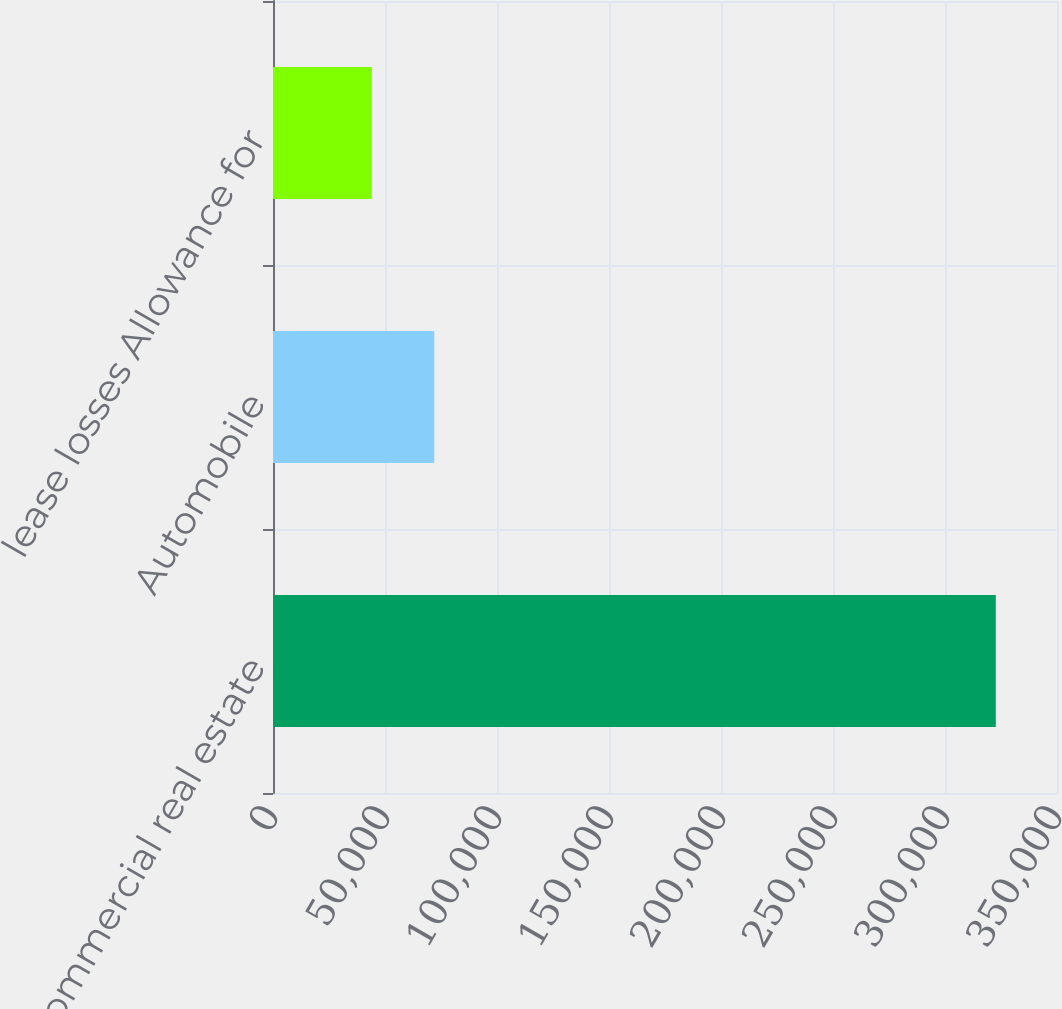Convert chart. <chart><loc_0><loc_0><loc_500><loc_500><bar_chart><fcel>Commercial real estate<fcel>Automobile<fcel>lease losses Allowance for<nl><fcel>322681<fcel>71993.2<fcel>44139<nl></chart> 